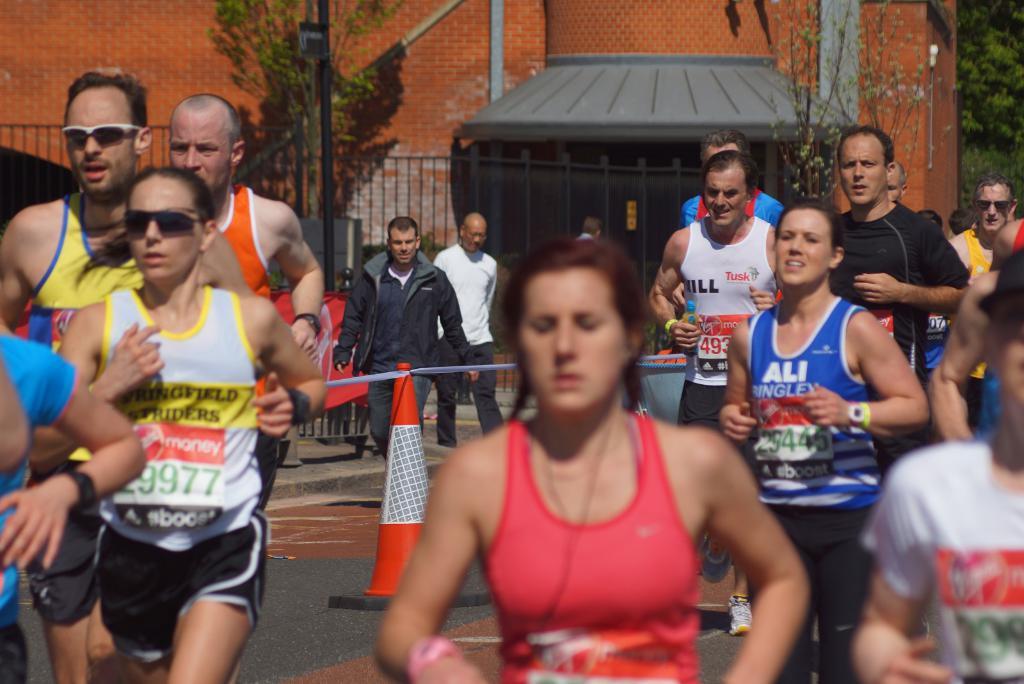Who is the sponsor or brand on the man in white in the back?
Make the answer very short. Tusk. What is the number on the runner to the left?
Provide a succinct answer. 29977. 